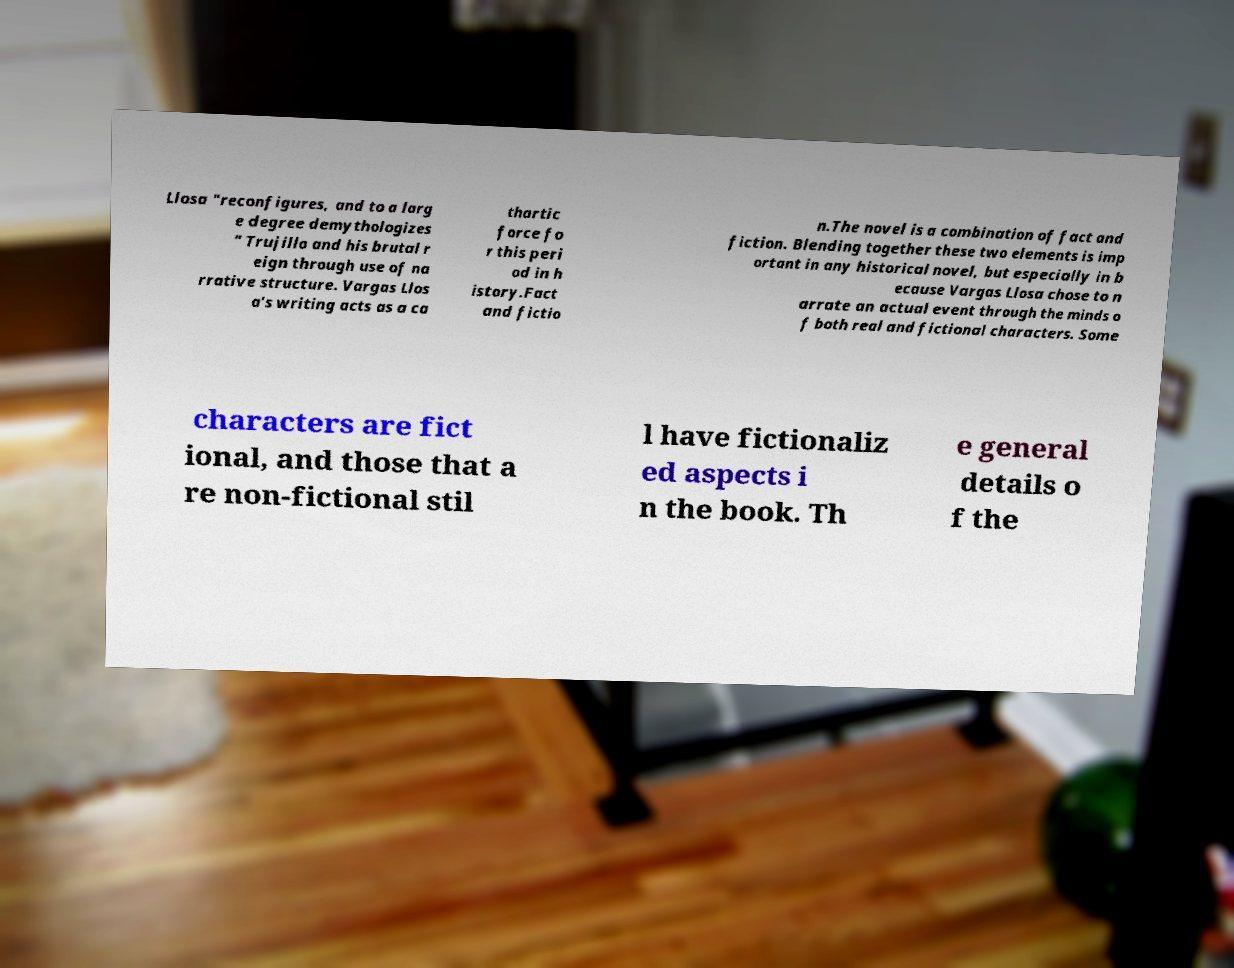Can you read and provide the text displayed in the image?This photo seems to have some interesting text. Can you extract and type it out for me? Llosa "reconfigures, and to a larg e degree demythologizes " Trujillo and his brutal r eign through use of na rrative structure. Vargas Llos a's writing acts as a ca thartic force fo r this peri od in h istory.Fact and fictio n.The novel is a combination of fact and fiction. Blending together these two elements is imp ortant in any historical novel, but especially in b ecause Vargas Llosa chose to n arrate an actual event through the minds o f both real and fictional characters. Some characters are fict ional, and those that a re non-fictional stil l have fictionaliz ed aspects i n the book. Th e general details o f the 